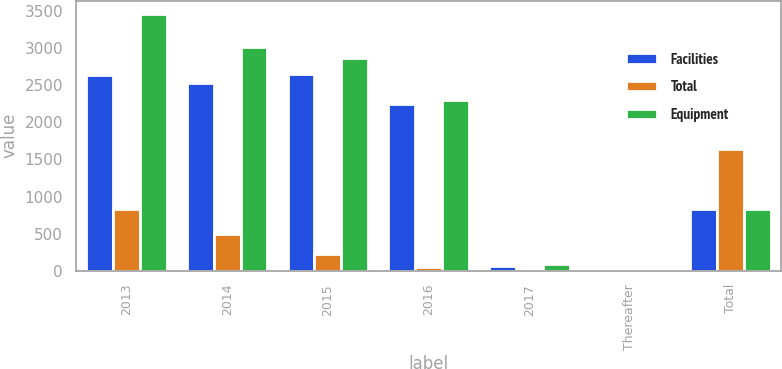Convert chart. <chart><loc_0><loc_0><loc_500><loc_500><stacked_bar_chart><ecel><fcel>2013<fcel>2014<fcel>2015<fcel>2016<fcel>2017<fcel>Thereafter<fcel>Total<nl><fcel>Facilities<fcel>2636<fcel>2525<fcel>2654<fcel>2254<fcel>59<fcel>2<fcel>831<nl><fcel>Total<fcel>831<fcel>494<fcel>221<fcel>46<fcel>25<fcel>27<fcel>1644<nl><fcel>Equipment<fcel>3467<fcel>3019<fcel>2875<fcel>2300<fcel>84<fcel>29<fcel>831<nl></chart> 